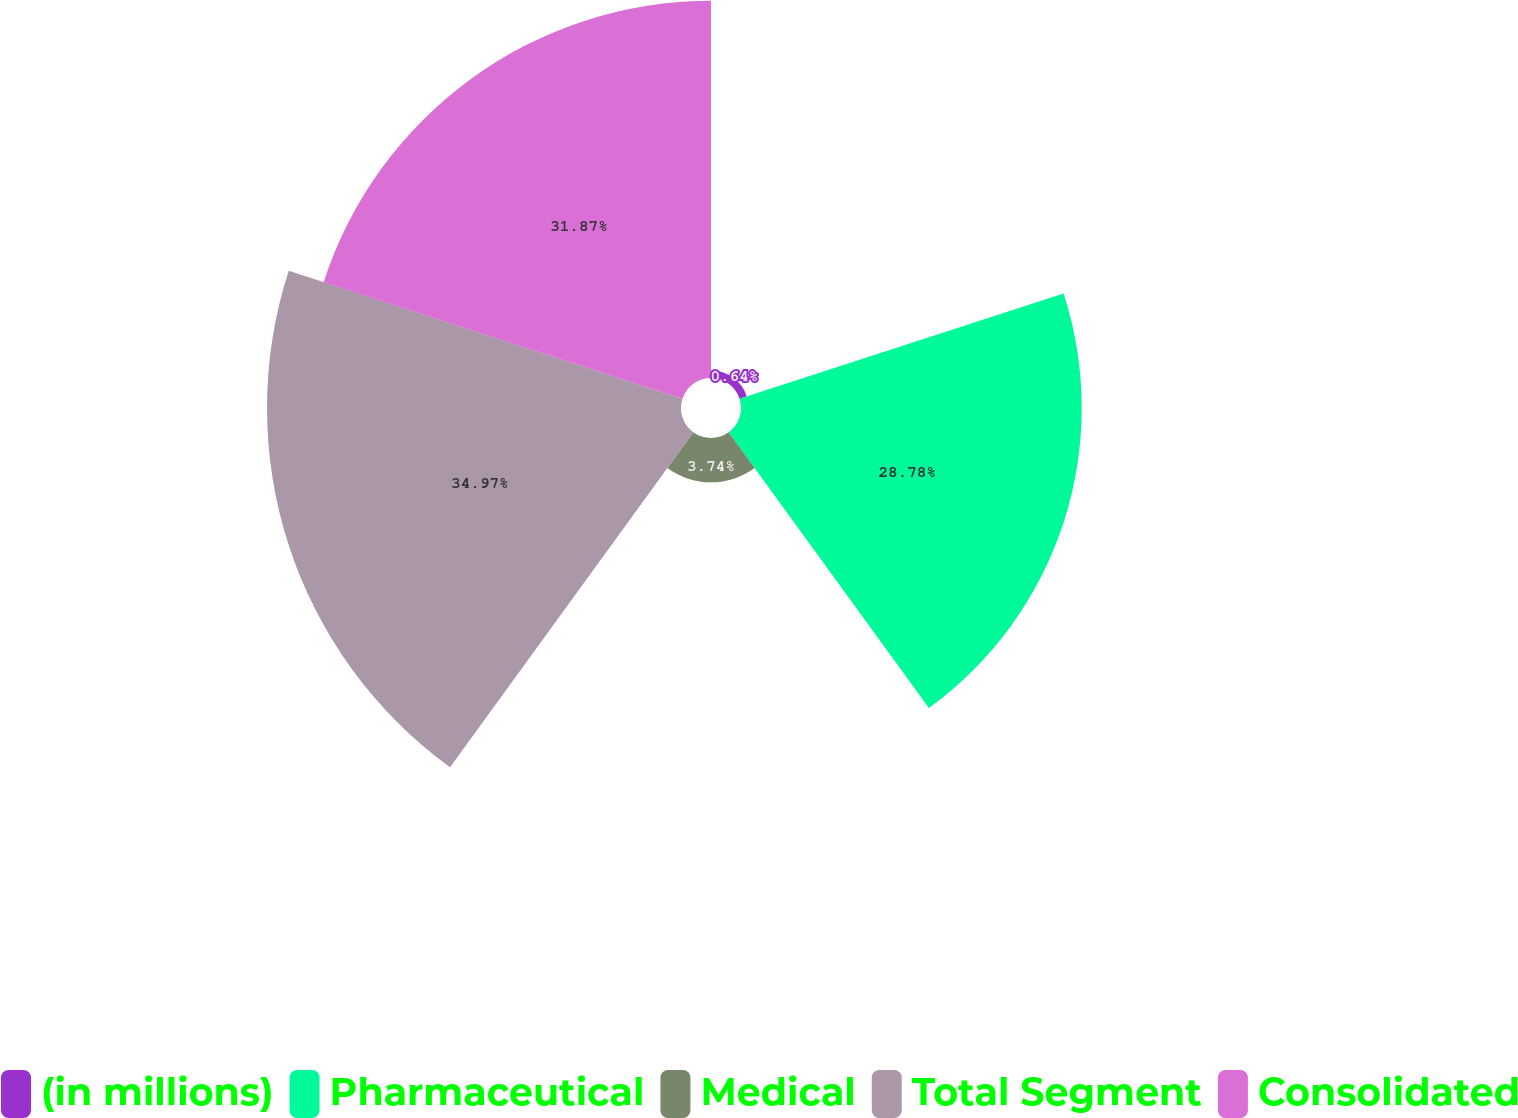<chart> <loc_0><loc_0><loc_500><loc_500><pie_chart><fcel>(in millions)<fcel>Pharmaceutical<fcel>Medical<fcel>Total Segment<fcel>Consolidated<nl><fcel>0.64%<fcel>28.78%<fcel>3.74%<fcel>34.97%<fcel>31.87%<nl></chart> 